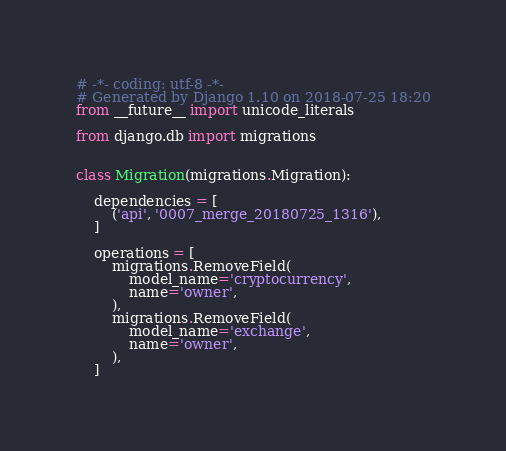<code> <loc_0><loc_0><loc_500><loc_500><_Python_># -*- coding: utf-8 -*-
# Generated by Django 1.10 on 2018-07-25 18:20
from __future__ import unicode_literals

from django.db import migrations


class Migration(migrations.Migration):

    dependencies = [
        ('api', '0007_merge_20180725_1316'),
    ]

    operations = [
        migrations.RemoveField(
            model_name='cryptocurrency',
            name='owner',
        ),
        migrations.RemoveField(
            model_name='exchange',
            name='owner',
        ),
    ]
</code> 